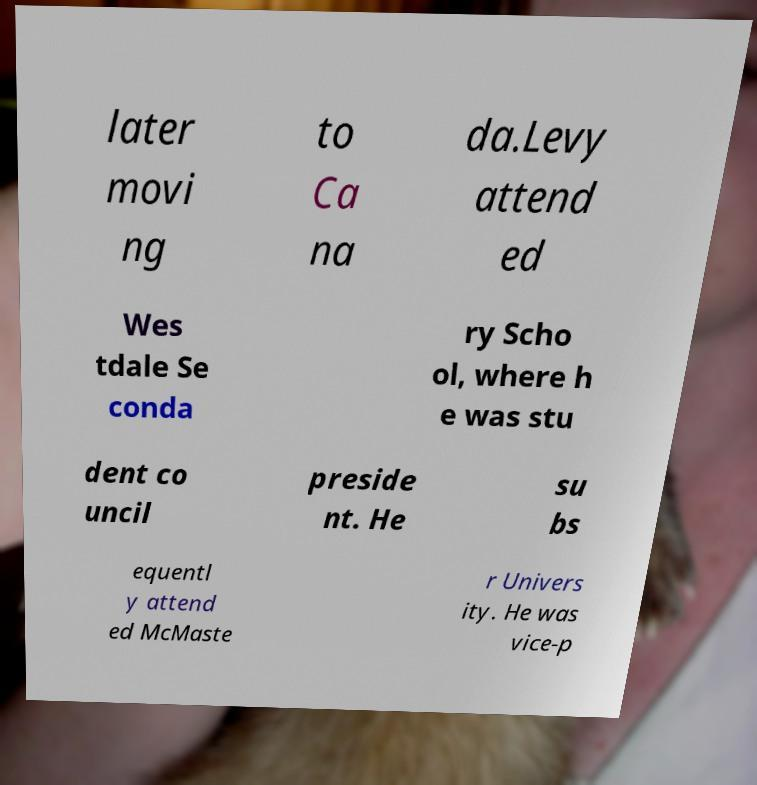There's text embedded in this image that I need extracted. Can you transcribe it verbatim? later movi ng to Ca na da.Levy attend ed Wes tdale Se conda ry Scho ol, where h e was stu dent co uncil preside nt. He su bs equentl y attend ed McMaste r Univers ity. He was vice-p 